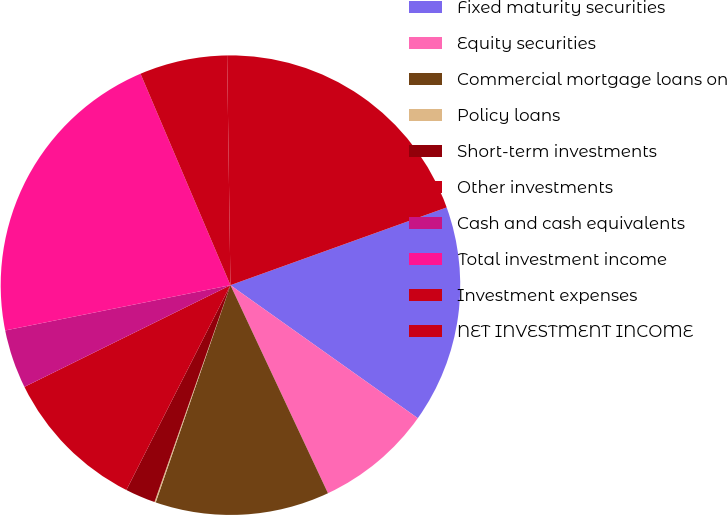Convert chart. <chart><loc_0><loc_0><loc_500><loc_500><pie_chart><fcel>Fixed maturity securities<fcel>Equity securities<fcel>Commercial mortgage loans on<fcel>Policy loans<fcel>Short-term investments<fcel>Other investments<fcel>Cash and cash equivalents<fcel>Total investment income<fcel>Investment expenses<fcel>NET INVESTMENT INCOME<nl><fcel>15.32%<fcel>8.2%<fcel>12.25%<fcel>0.09%<fcel>2.12%<fcel>10.22%<fcel>4.14%<fcel>21.76%<fcel>6.17%<fcel>19.74%<nl></chart> 